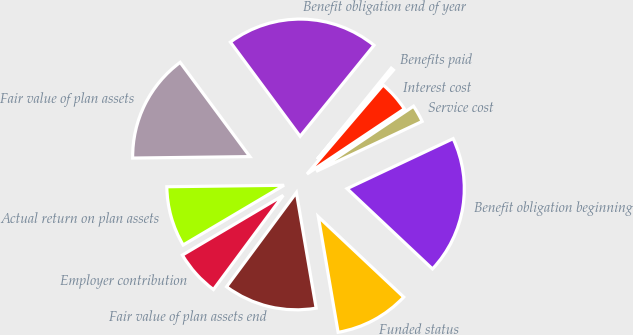Convert chart to OTSL. <chart><loc_0><loc_0><loc_500><loc_500><pie_chart><fcel>Benefit obligation beginning<fcel>Service cost<fcel>Interest cost<fcel>Benefits paid<fcel>Benefit obligation end of year<fcel>Fair value of plan assets<fcel>Actual return on plan assets<fcel>Employer contribution<fcel>Fair value of plan assets end<fcel>Funded status<nl><fcel>19.02%<fcel>2.38%<fcel>4.36%<fcel>0.4%<fcel>20.99%<fcel>15.06%<fcel>8.31%<fcel>6.34%<fcel>12.85%<fcel>10.29%<nl></chart> 